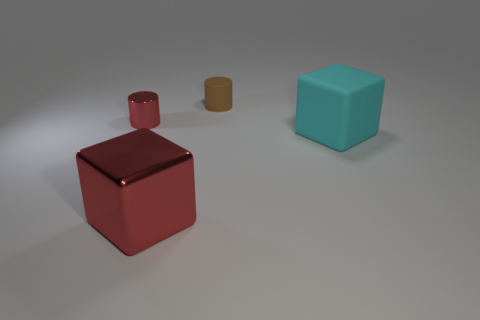Are any big brown cylinders visible?
Offer a very short reply. No. There is a red thing that is in front of the red cylinder; is it the same size as the tiny brown matte object?
Offer a very short reply. No. Are there fewer large brown balls than things?
Offer a terse response. Yes. What is the shape of the red object that is behind the cube left of the matte object that is behind the big rubber object?
Offer a very short reply. Cylinder. Is there another cylinder made of the same material as the red cylinder?
Your answer should be compact. No. Do the big thing that is on the left side of the large cyan block and the small object that is in front of the tiny brown matte object have the same color?
Ensure brevity in your answer.  Yes. Is the number of large objects that are to the left of the small red metallic thing less than the number of tiny brown rubber cylinders?
Keep it short and to the point. Yes. What number of things are brown matte spheres or shiny things that are left of the large red metallic thing?
Ensure brevity in your answer.  1. What color is the tiny object that is made of the same material as the cyan cube?
Your response must be concise. Brown. What number of things are cyan rubber things or brown matte cylinders?
Your answer should be compact. 2. 